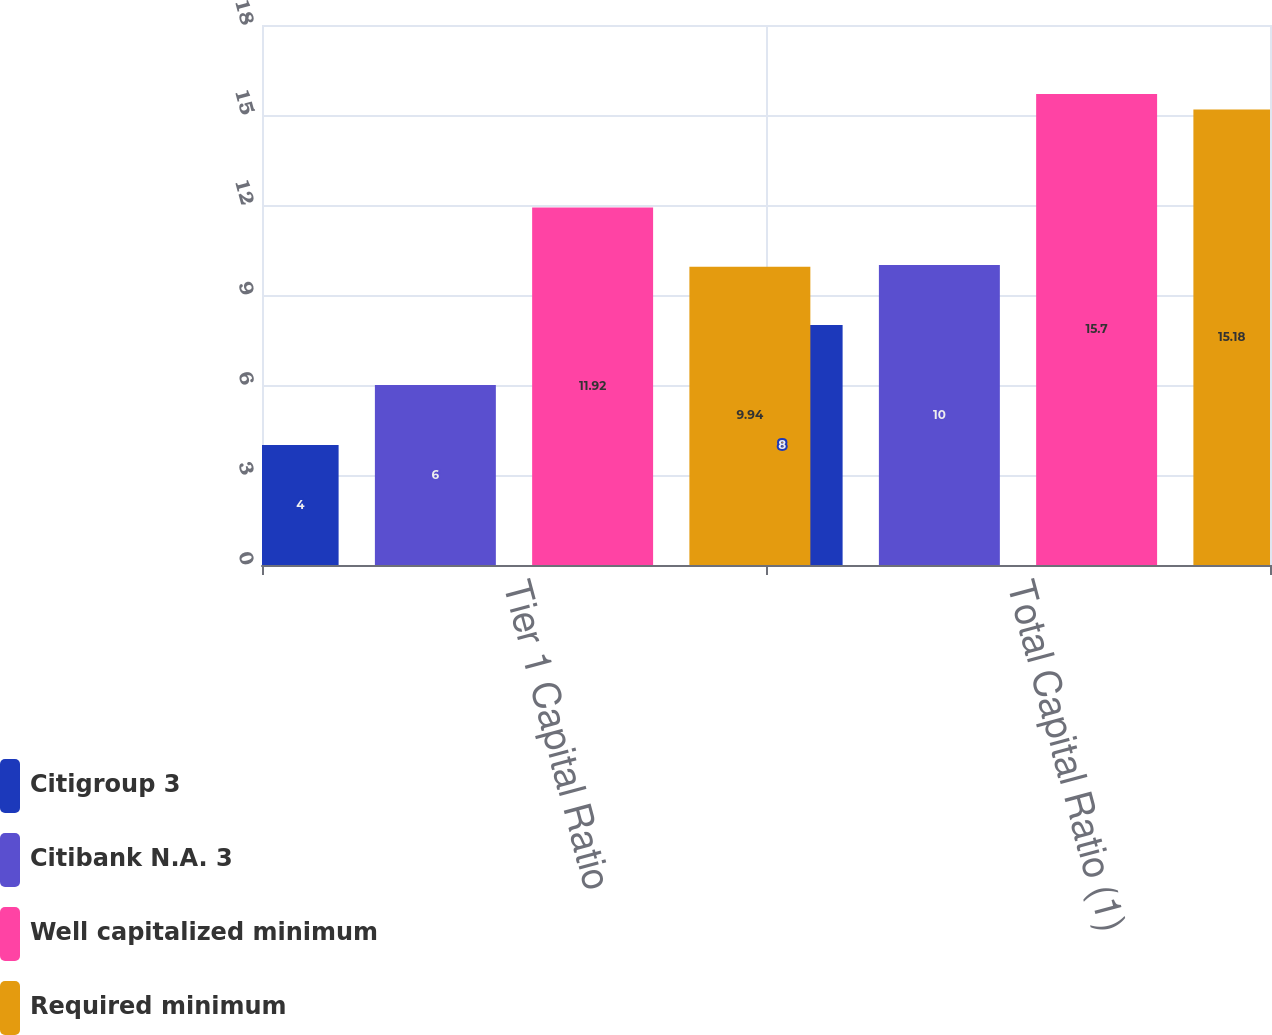Convert chart. <chart><loc_0><loc_0><loc_500><loc_500><stacked_bar_chart><ecel><fcel>Tier 1 Capital Ratio<fcel>Total Capital Ratio (1)<nl><fcel>Citigroup 3<fcel>4<fcel>8<nl><fcel>Citibank N.A. 3<fcel>6<fcel>10<nl><fcel>Well capitalized minimum<fcel>11.92<fcel>15.7<nl><fcel>Required minimum<fcel>9.94<fcel>15.18<nl></chart> 